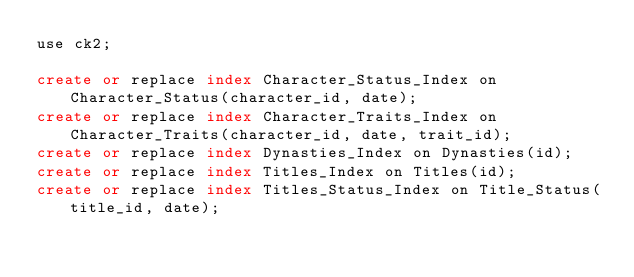<code> <loc_0><loc_0><loc_500><loc_500><_SQL_>use ck2;

create or replace index Character_Status_Index on Character_Status(character_id, date);
create or replace index Character_Traits_Index on Character_Traits(character_id, date, trait_id);
create or replace index Dynasties_Index on Dynasties(id);
create or replace index Titles_Index on Titles(id);
create or replace index Titles_Status_Index on Title_Status(title_id, date);

</code> 